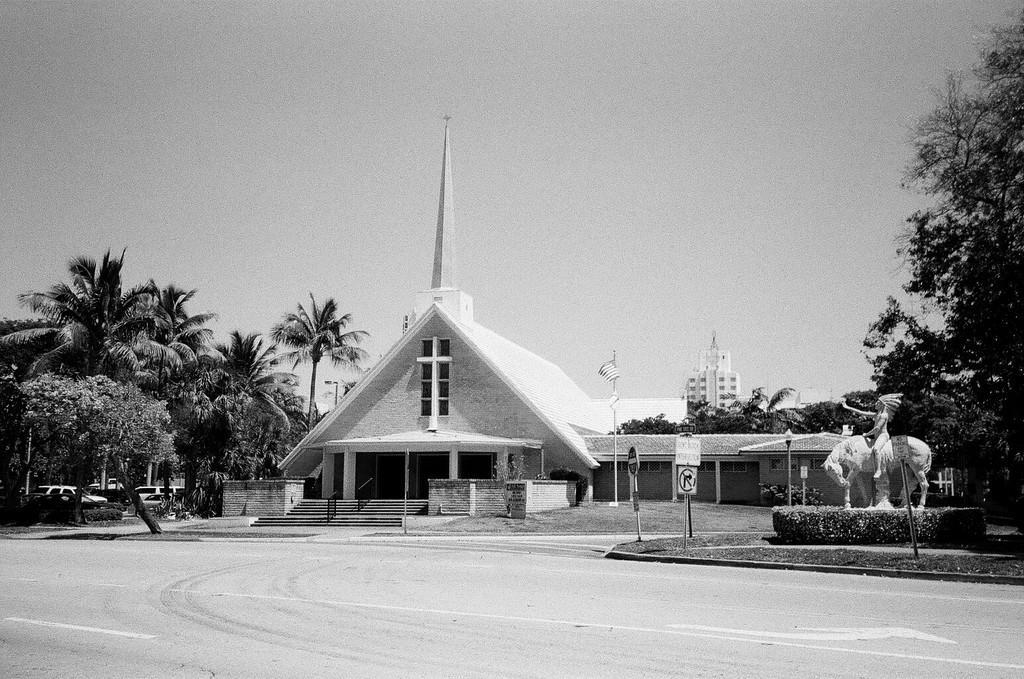Could you give a brief overview of what you see in this image? This is a black and white image. In this image we can see building with windows, pillars and steps with railings. Near to the building there are trees and vehicles. Also there are sign boards with poles. And there is a statue. In the background there is another building. Also there is sky. 